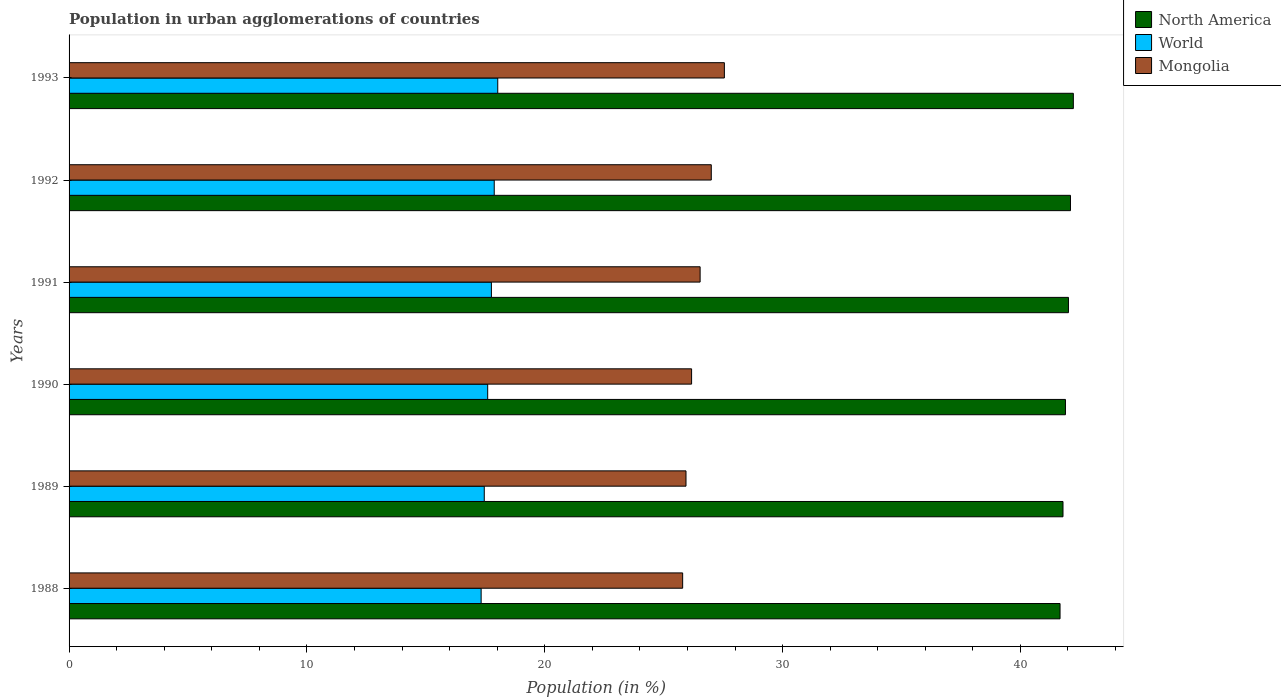How many groups of bars are there?
Make the answer very short. 6. Are the number of bars on each tick of the Y-axis equal?
Your answer should be compact. Yes. How many bars are there on the 5th tick from the top?
Make the answer very short. 3. How many bars are there on the 4th tick from the bottom?
Give a very brief answer. 3. What is the label of the 3rd group of bars from the top?
Your answer should be very brief. 1991. What is the percentage of population in urban agglomerations in North America in 1993?
Your answer should be compact. 42.23. Across all years, what is the maximum percentage of population in urban agglomerations in North America?
Your answer should be very brief. 42.23. Across all years, what is the minimum percentage of population in urban agglomerations in North America?
Provide a short and direct response. 41.67. In which year was the percentage of population in urban agglomerations in North America minimum?
Offer a very short reply. 1988. What is the total percentage of population in urban agglomerations in World in the graph?
Make the answer very short. 106.04. What is the difference between the percentage of population in urban agglomerations in North America in 1992 and that in 1993?
Provide a succinct answer. -0.12. What is the difference between the percentage of population in urban agglomerations in North America in 1990 and the percentage of population in urban agglomerations in Mongolia in 1992?
Your answer should be compact. 14.89. What is the average percentage of population in urban agglomerations in North America per year?
Ensure brevity in your answer.  41.95. In the year 1992, what is the difference between the percentage of population in urban agglomerations in Mongolia and percentage of population in urban agglomerations in North America?
Provide a short and direct response. -15.1. In how many years, is the percentage of population in urban agglomerations in Mongolia greater than 10 %?
Provide a short and direct response. 6. What is the ratio of the percentage of population in urban agglomerations in Mongolia in 1988 to that in 1991?
Offer a very short reply. 0.97. Is the percentage of population in urban agglomerations in North America in 1990 less than that in 1992?
Provide a succinct answer. Yes. What is the difference between the highest and the second highest percentage of population in urban agglomerations in Mongolia?
Your answer should be compact. 0.55. What is the difference between the highest and the lowest percentage of population in urban agglomerations in North America?
Your answer should be compact. 0.56. Is the sum of the percentage of population in urban agglomerations in North America in 1988 and 1993 greater than the maximum percentage of population in urban agglomerations in Mongolia across all years?
Provide a short and direct response. Yes. What does the 1st bar from the bottom in 1989 represents?
Give a very brief answer. North America. What is the difference between two consecutive major ticks on the X-axis?
Make the answer very short. 10. Are the values on the major ticks of X-axis written in scientific E-notation?
Your answer should be very brief. No. Does the graph contain any zero values?
Provide a short and direct response. No. Does the graph contain grids?
Keep it short and to the point. No. What is the title of the graph?
Make the answer very short. Population in urban agglomerations of countries. Does "Turkmenistan" appear as one of the legend labels in the graph?
Offer a terse response. No. What is the label or title of the X-axis?
Provide a succinct answer. Population (in %). What is the label or title of the Y-axis?
Make the answer very short. Years. What is the Population (in %) in North America in 1988?
Keep it short and to the point. 41.67. What is the Population (in %) in World in 1988?
Your answer should be very brief. 17.33. What is the Population (in %) in Mongolia in 1988?
Provide a succinct answer. 25.8. What is the Population (in %) in North America in 1989?
Provide a succinct answer. 41.79. What is the Population (in %) of World in 1989?
Offer a terse response. 17.46. What is the Population (in %) in Mongolia in 1989?
Offer a very short reply. 25.94. What is the Population (in %) of North America in 1990?
Offer a terse response. 41.89. What is the Population (in %) in World in 1990?
Make the answer very short. 17.6. What is the Population (in %) in Mongolia in 1990?
Offer a terse response. 26.17. What is the Population (in %) in North America in 1991?
Keep it short and to the point. 42.02. What is the Population (in %) in World in 1991?
Keep it short and to the point. 17.76. What is the Population (in %) in Mongolia in 1991?
Provide a succinct answer. 26.53. What is the Population (in %) in North America in 1992?
Make the answer very short. 42.11. What is the Population (in %) of World in 1992?
Your answer should be very brief. 17.88. What is the Population (in %) in Mongolia in 1992?
Make the answer very short. 27. What is the Population (in %) of North America in 1993?
Offer a very short reply. 42.23. What is the Population (in %) in World in 1993?
Give a very brief answer. 18.02. What is the Population (in %) of Mongolia in 1993?
Keep it short and to the point. 27.55. Across all years, what is the maximum Population (in %) of North America?
Provide a short and direct response. 42.23. Across all years, what is the maximum Population (in %) of World?
Ensure brevity in your answer.  18.02. Across all years, what is the maximum Population (in %) in Mongolia?
Provide a succinct answer. 27.55. Across all years, what is the minimum Population (in %) of North America?
Provide a succinct answer. 41.67. Across all years, what is the minimum Population (in %) in World?
Your answer should be very brief. 17.33. Across all years, what is the minimum Population (in %) of Mongolia?
Your answer should be very brief. 25.8. What is the total Population (in %) of North America in the graph?
Your answer should be very brief. 251.71. What is the total Population (in %) of World in the graph?
Your answer should be very brief. 106.04. What is the total Population (in %) in Mongolia in the graph?
Offer a very short reply. 159. What is the difference between the Population (in %) of North America in 1988 and that in 1989?
Your answer should be compact. -0.12. What is the difference between the Population (in %) of World in 1988 and that in 1989?
Your response must be concise. -0.13. What is the difference between the Population (in %) in Mongolia in 1988 and that in 1989?
Give a very brief answer. -0.14. What is the difference between the Population (in %) in North America in 1988 and that in 1990?
Your answer should be compact. -0.23. What is the difference between the Population (in %) of World in 1988 and that in 1990?
Provide a succinct answer. -0.28. What is the difference between the Population (in %) in Mongolia in 1988 and that in 1990?
Keep it short and to the point. -0.38. What is the difference between the Population (in %) in North America in 1988 and that in 1991?
Your answer should be very brief. -0.35. What is the difference between the Population (in %) in World in 1988 and that in 1991?
Offer a terse response. -0.43. What is the difference between the Population (in %) in Mongolia in 1988 and that in 1991?
Offer a terse response. -0.73. What is the difference between the Population (in %) of North America in 1988 and that in 1992?
Make the answer very short. -0.44. What is the difference between the Population (in %) of World in 1988 and that in 1992?
Offer a terse response. -0.55. What is the difference between the Population (in %) in Mongolia in 1988 and that in 1992?
Give a very brief answer. -1.2. What is the difference between the Population (in %) of North America in 1988 and that in 1993?
Ensure brevity in your answer.  -0.56. What is the difference between the Population (in %) in World in 1988 and that in 1993?
Your response must be concise. -0.7. What is the difference between the Population (in %) in Mongolia in 1988 and that in 1993?
Make the answer very short. -1.75. What is the difference between the Population (in %) of North America in 1989 and that in 1990?
Give a very brief answer. -0.1. What is the difference between the Population (in %) in World in 1989 and that in 1990?
Your answer should be very brief. -0.14. What is the difference between the Population (in %) in Mongolia in 1989 and that in 1990?
Make the answer very short. -0.23. What is the difference between the Population (in %) in North America in 1989 and that in 1991?
Provide a short and direct response. -0.23. What is the difference between the Population (in %) of World in 1989 and that in 1991?
Your answer should be very brief. -0.3. What is the difference between the Population (in %) in Mongolia in 1989 and that in 1991?
Give a very brief answer. -0.59. What is the difference between the Population (in %) in North America in 1989 and that in 1992?
Your answer should be compact. -0.32. What is the difference between the Population (in %) in World in 1989 and that in 1992?
Make the answer very short. -0.42. What is the difference between the Population (in %) in Mongolia in 1989 and that in 1992?
Your response must be concise. -1.06. What is the difference between the Population (in %) in North America in 1989 and that in 1993?
Make the answer very short. -0.43. What is the difference between the Population (in %) of World in 1989 and that in 1993?
Offer a very short reply. -0.57. What is the difference between the Population (in %) in Mongolia in 1989 and that in 1993?
Provide a succinct answer. -1.61. What is the difference between the Population (in %) in North America in 1990 and that in 1991?
Ensure brevity in your answer.  -0.13. What is the difference between the Population (in %) of World in 1990 and that in 1991?
Your answer should be compact. -0.16. What is the difference between the Population (in %) in Mongolia in 1990 and that in 1991?
Your answer should be very brief. -0.36. What is the difference between the Population (in %) in North America in 1990 and that in 1992?
Your answer should be very brief. -0.21. What is the difference between the Population (in %) of World in 1990 and that in 1992?
Your response must be concise. -0.28. What is the difference between the Population (in %) in Mongolia in 1990 and that in 1992?
Ensure brevity in your answer.  -0.83. What is the difference between the Population (in %) in North America in 1990 and that in 1993?
Provide a short and direct response. -0.33. What is the difference between the Population (in %) of World in 1990 and that in 1993?
Provide a short and direct response. -0.42. What is the difference between the Population (in %) of Mongolia in 1990 and that in 1993?
Keep it short and to the point. -1.38. What is the difference between the Population (in %) in North America in 1991 and that in 1992?
Offer a terse response. -0.09. What is the difference between the Population (in %) in World in 1991 and that in 1992?
Provide a succinct answer. -0.12. What is the difference between the Population (in %) in Mongolia in 1991 and that in 1992?
Your answer should be compact. -0.47. What is the difference between the Population (in %) in North America in 1991 and that in 1993?
Make the answer very short. -0.21. What is the difference between the Population (in %) in World in 1991 and that in 1993?
Offer a very short reply. -0.27. What is the difference between the Population (in %) of Mongolia in 1991 and that in 1993?
Offer a terse response. -1.02. What is the difference between the Population (in %) of North America in 1992 and that in 1993?
Give a very brief answer. -0.12. What is the difference between the Population (in %) of World in 1992 and that in 1993?
Keep it short and to the point. -0.15. What is the difference between the Population (in %) of Mongolia in 1992 and that in 1993?
Your answer should be compact. -0.55. What is the difference between the Population (in %) in North America in 1988 and the Population (in %) in World in 1989?
Make the answer very short. 24.21. What is the difference between the Population (in %) of North America in 1988 and the Population (in %) of Mongolia in 1989?
Make the answer very short. 15.73. What is the difference between the Population (in %) of World in 1988 and the Population (in %) of Mongolia in 1989?
Provide a short and direct response. -8.61. What is the difference between the Population (in %) of North America in 1988 and the Population (in %) of World in 1990?
Your answer should be very brief. 24.07. What is the difference between the Population (in %) in North America in 1988 and the Population (in %) in Mongolia in 1990?
Provide a succinct answer. 15.49. What is the difference between the Population (in %) in World in 1988 and the Population (in %) in Mongolia in 1990?
Give a very brief answer. -8.85. What is the difference between the Population (in %) in North America in 1988 and the Population (in %) in World in 1991?
Your answer should be compact. 23.91. What is the difference between the Population (in %) of North America in 1988 and the Population (in %) of Mongolia in 1991?
Your answer should be compact. 15.13. What is the difference between the Population (in %) of World in 1988 and the Population (in %) of Mongolia in 1991?
Make the answer very short. -9.21. What is the difference between the Population (in %) of North America in 1988 and the Population (in %) of World in 1992?
Offer a very short reply. 23.79. What is the difference between the Population (in %) in North America in 1988 and the Population (in %) in Mongolia in 1992?
Your response must be concise. 14.66. What is the difference between the Population (in %) of World in 1988 and the Population (in %) of Mongolia in 1992?
Your response must be concise. -9.68. What is the difference between the Population (in %) in North America in 1988 and the Population (in %) in World in 1993?
Ensure brevity in your answer.  23.64. What is the difference between the Population (in %) in North America in 1988 and the Population (in %) in Mongolia in 1993?
Your response must be concise. 14.11. What is the difference between the Population (in %) of World in 1988 and the Population (in %) of Mongolia in 1993?
Your response must be concise. -10.23. What is the difference between the Population (in %) in North America in 1989 and the Population (in %) in World in 1990?
Give a very brief answer. 24.19. What is the difference between the Population (in %) of North America in 1989 and the Population (in %) of Mongolia in 1990?
Offer a terse response. 15.62. What is the difference between the Population (in %) of World in 1989 and the Population (in %) of Mongolia in 1990?
Provide a succinct answer. -8.72. What is the difference between the Population (in %) in North America in 1989 and the Population (in %) in World in 1991?
Keep it short and to the point. 24.03. What is the difference between the Population (in %) in North America in 1989 and the Population (in %) in Mongolia in 1991?
Offer a very short reply. 15.26. What is the difference between the Population (in %) of World in 1989 and the Population (in %) of Mongolia in 1991?
Give a very brief answer. -9.08. What is the difference between the Population (in %) of North America in 1989 and the Population (in %) of World in 1992?
Give a very brief answer. 23.91. What is the difference between the Population (in %) of North America in 1989 and the Population (in %) of Mongolia in 1992?
Offer a terse response. 14.79. What is the difference between the Population (in %) of World in 1989 and the Population (in %) of Mongolia in 1992?
Provide a short and direct response. -9.55. What is the difference between the Population (in %) in North America in 1989 and the Population (in %) in World in 1993?
Your answer should be compact. 23.77. What is the difference between the Population (in %) in North America in 1989 and the Population (in %) in Mongolia in 1993?
Ensure brevity in your answer.  14.24. What is the difference between the Population (in %) in World in 1989 and the Population (in %) in Mongolia in 1993?
Ensure brevity in your answer.  -10.1. What is the difference between the Population (in %) in North America in 1990 and the Population (in %) in World in 1991?
Provide a succinct answer. 24.14. What is the difference between the Population (in %) in North America in 1990 and the Population (in %) in Mongolia in 1991?
Provide a short and direct response. 15.36. What is the difference between the Population (in %) in World in 1990 and the Population (in %) in Mongolia in 1991?
Provide a succinct answer. -8.93. What is the difference between the Population (in %) of North America in 1990 and the Population (in %) of World in 1992?
Offer a terse response. 24.02. What is the difference between the Population (in %) of North America in 1990 and the Population (in %) of Mongolia in 1992?
Offer a terse response. 14.89. What is the difference between the Population (in %) of World in 1990 and the Population (in %) of Mongolia in 1992?
Provide a short and direct response. -9.4. What is the difference between the Population (in %) in North America in 1990 and the Population (in %) in World in 1993?
Provide a short and direct response. 23.87. What is the difference between the Population (in %) in North America in 1990 and the Population (in %) in Mongolia in 1993?
Offer a very short reply. 14.34. What is the difference between the Population (in %) in World in 1990 and the Population (in %) in Mongolia in 1993?
Keep it short and to the point. -9.95. What is the difference between the Population (in %) in North America in 1991 and the Population (in %) in World in 1992?
Your answer should be compact. 24.14. What is the difference between the Population (in %) in North America in 1991 and the Population (in %) in Mongolia in 1992?
Give a very brief answer. 15.02. What is the difference between the Population (in %) of World in 1991 and the Population (in %) of Mongolia in 1992?
Ensure brevity in your answer.  -9.24. What is the difference between the Population (in %) of North America in 1991 and the Population (in %) of World in 1993?
Offer a very short reply. 24. What is the difference between the Population (in %) in North America in 1991 and the Population (in %) in Mongolia in 1993?
Give a very brief answer. 14.47. What is the difference between the Population (in %) in World in 1991 and the Population (in %) in Mongolia in 1993?
Offer a terse response. -9.8. What is the difference between the Population (in %) in North America in 1992 and the Population (in %) in World in 1993?
Make the answer very short. 24.08. What is the difference between the Population (in %) of North America in 1992 and the Population (in %) of Mongolia in 1993?
Provide a short and direct response. 14.55. What is the difference between the Population (in %) of World in 1992 and the Population (in %) of Mongolia in 1993?
Offer a very short reply. -9.68. What is the average Population (in %) of North America per year?
Your answer should be compact. 41.95. What is the average Population (in %) in World per year?
Offer a terse response. 17.67. What is the average Population (in %) in Mongolia per year?
Provide a short and direct response. 26.5. In the year 1988, what is the difference between the Population (in %) of North America and Population (in %) of World?
Your response must be concise. 24.34. In the year 1988, what is the difference between the Population (in %) of North America and Population (in %) of Mongolia?
Make the answer very short. 15.87. In the year 1988, what is the difference between the Population (in %) of World and Population (in %) of Mongolia?
Ensure brevity in your answer.  -8.47. In the year 1989, what is the difference between the Population (in %) in North America and Population (in %) in World?
Your response must be concise. 24.33. In the year 1989, what is the difference between the Population (in %) in North America and Population (in %) in Mongolia?
Provide a succinct answer. 15.85. In the year 1989, what is the difference between the Population (in %) in World and Population (in %) in Mongolia?
Your response must be concise. -8.48. In the year 1990, what is the difference between the Population (in %) of North America and Population (in %) of World?
Make the answer very short. 24.29. In the year 1990, what is the difference between the Population (in %) in North America and Population (in %) in Mongolia?
Ensure brevity in your answer.  15.72. In the year 1990, what is the difference between the Population (in %) in World and Population (in %) in Mongolia?
Your response must be concise. -8.57. In the year 1991, what is the difference between the Population (in %) of North America and Population (in %) of World?
Give a very brief answer. 24.26. In the year 1991, what is the difference between the Population (in %) in North America and Population (in %) in Mongolia?
Your answer should be very brief. 15.49. In the year 1991, what is the difference between the Population (in %) in World and Population (in %) in Mongolia?
Give a very brief answer. -8.78. In the year 1992, what is the difference between the Population (in %) in North America and Population (in %) in World?
Make the answer very short. 24.23. In the year 1992, what is the difference between the Population (in %) in North America and Population (in %) in Mongolia?
Your response must be concise. 15.1. In the year 1992, what is the difference between the Population (in %) in World and Population (in %) in Mongolia?
Ensure brevity in your answer.  -9.13. In the year 1993, what is the difference between the Population (in %) in North America and Population (in %) in World?
Make the answer very short. 24.2. In the year 1993, what is the difference between the Population (in %) in North America and Population (in %) in Mongolia?
Your answer should be compact. 14.67. In the year 1993, what is the difference between the Population (in %) of World and Population (in %) of Mongolia?
Offer a terse response. -9.53. What is the ratio of the Population (in %) in North America in 1988 to that in 1989?
Your answer should be very brief. 1. What is the ratio of the Population (in %) of Mongolia in 1988 to that in 1989?
Your answer should be compact. 0.99. What is the ratio of the Population (in %) in World in 1988 to that in 1990?
Provide a short and direct response. 0.98. What is the ratio of the Population (in %) of Mongolia in 1988 to that in 1990?
Keep it short and to the point. 0.99. What is the ratio of the Population (in %) of World in 1988 to that in 1991?
Your response must be concise. 0.98. What is the ratio of the Population (in %) of Mongolia in 1988 to that in 1991?
Provide a short and direct response. 0.97. What is the ratio of the Population (in %) of North America in 1988 to that in 1992?
Your answer should be very brief. 0.99. What is the ratio of the Population (in %) in World in 1988 to that in 1992?
Provide a succinct answer. 0.97. What is the ratio of the Population (in %) in Mongolia in 1988 to that in 1992?
Give a very brief answer. 0.96. What is the ratio of the Population (in %) of North America in 1988 to that in 1993?
Provide a succinct answer. 0.99. What is the ratio of the Population (in %) of World in 1988 to that in 1993?
Your answer should be very brief. 0.96. What is the ratio of the Population (in %) of Mongolia in 1988 to that in 1993?
Your answer should be compact. 0.94. What is the ratio of the Population (in %) of North America in 1989 to that in 1990?
Give a very brief answer. 1. What is the ratio of the Population (in %) of World in 1989 to that in 1990?
Keep it short and to the point. 0.99. What is the ratio of the Population (in %) of Mongolia in 1989 to that in 1990?
Give a very brief answer. 0.99. What is the ratio of the Population (in %) of North America in 1989 to that in 1991?
Your answer should be compact. 0.99. What is the ratio of the Population (in %) of World in 1989 to that in 1991?
Offer a terse response. 0.98. What is the ratio of the Population (in %) in Mongolia in 1989 to that in 1991?
Keep it short and to the point. 0.98. What is the ratio of the Population (in %) in North America in 1989 to that in 1992?
Your answer should be compact. 0.99. What is the ratio of the Population (in %) of World in 1989 to that in 1992?
Your answer should be compact. 0.98. What is the ratio of the Population (in %) in Mongolia in 1989 to that in 1992?
Provide a succinct answer. 0.96. What is the ratio of the Population (in %) of World in 1989 to that in 1993?
Provide a succinct answer. 0.97. What is the ratio of the Population (in %) of Mongolia in 1989 to that in 1993?
Provide a short and direct response. 0.94. What is the ratio of the Population (in %) in North America in 1990 to that in 1991?
Provide a succinct answer. 1. What is the ratio of the Population (in %) in Mongolia in 1990 to that in 1991?
Make the answer very short. 0.99. What is the ratio of the Population (in %) of World in 1990 to that in 1992?
Ensure brevity in your answer.  0.98. What is the ratio of the Population (in %) in Mongolia in 1990 to that in 1992?
Ensure brevity in your answer.  0.97. What is the ratio of the Population (in %) in North America in 1990 to that in 1993?
Provide a succinct answer. 0.99. What is the ratio of the Population (in %) in World in 1990 to that in 1993?
Make the answer very short. 0.98. What is the ratio of the Population (in %) of North America in 1991 to that in 1992?
Provide a succinct answer. 1. What is the ratio of the Population (in %) of World in 1991 to that in 1992?
Provide a succinct answer. 0.99. What is the ratio of the Population (in %) in Mongolia in 1991 to that in 1992?
Ensure brevity in your answer.  0.98. What is the ratio of the Population (in %) of World in 1991 to that in 1993?
Keep it short and to the point. 0.99. What is the ratio of the Population (in %) of Mongolia in 1992 to that in 1993?
Ensure brevity in your answer.  0.98. What is the difference between the highest and the second highest Population (in %) of North America?
Make the answer very short. 0.12. What is the difference between the highest and the second highest Population (in %) in World?
Give a very brief answer. 0.15. What is the difference between the highest and the second highest Population (in %) in Mongolia?
Make the answer very short. 0.55. What is the difference between the highest and the lowest Population (in %) in North America?
Keep it short and to the point. 0.56. What is the difference between the highest and the lowest Population (in %) in World?
Your answer should be very brief. 0.7. What is the difference between the highest and the lowest Population (in %) in Mongolia?
Give a very brief answer. 1.75. 